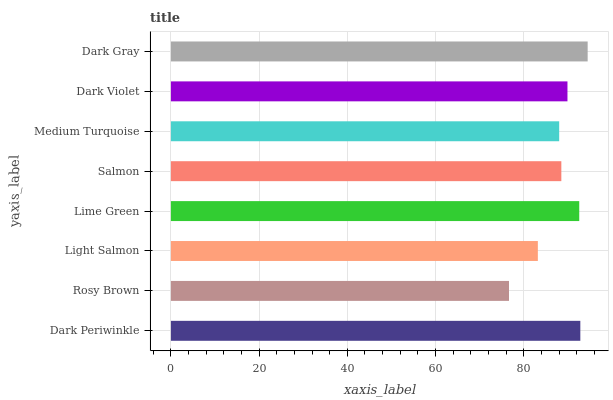Is Rosy Brown the minimum?
Answer yes or no. Yes. Is Dark Gray the maximum?
Answer yes or no. Yes. Is Light Salmon the minimum?
Answer yes or no. No. Is Light Salmon the maximum?
Answer yes or no. No. Is Light Salmon greater than Rosy Brown?
Answer yes or no. Yes. Is Rosy Brown less than Light Salmon?
Answer yes or no. Yes. Is Rosy Brown greater than Light Salmon?
Answer yes or no. No. Is Light Salmon less than Rosy Brown?
Answer yes or no. No. Is Dark Violet the high median?
Answer yes or no. Yes. Is Salmon the low median?
Answer yes or no. Yes. Is Lime Green the high median?
Answer yes or no. No. Is Lime Green the low median?
Answer yes or no. No. 